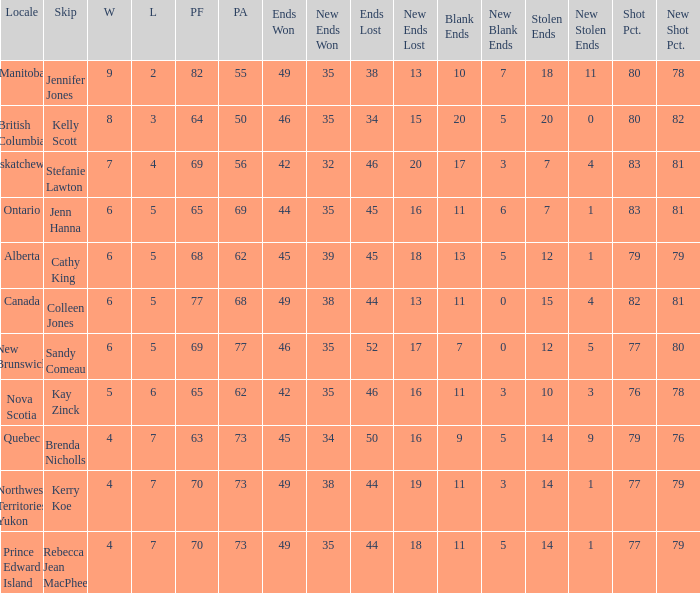What is the total number of ends won when the locale is Northwest Territories Yukon? 1.0. 